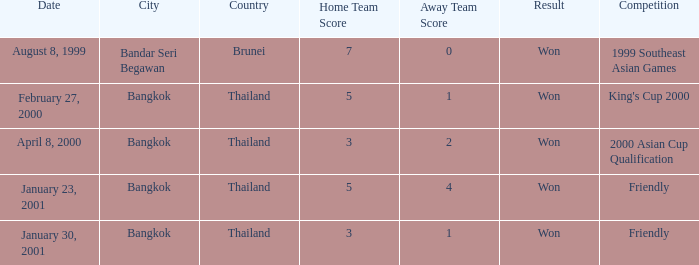What was the score from the king's cup 2000? 5–1. 